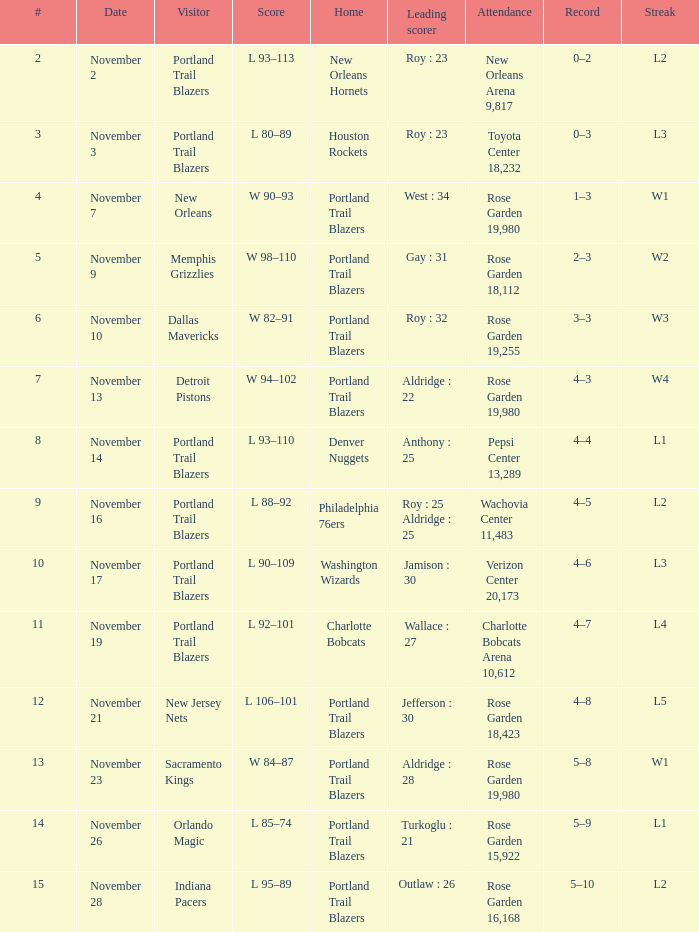What is the total number of date where visitor is new jersey nets 1.0. 